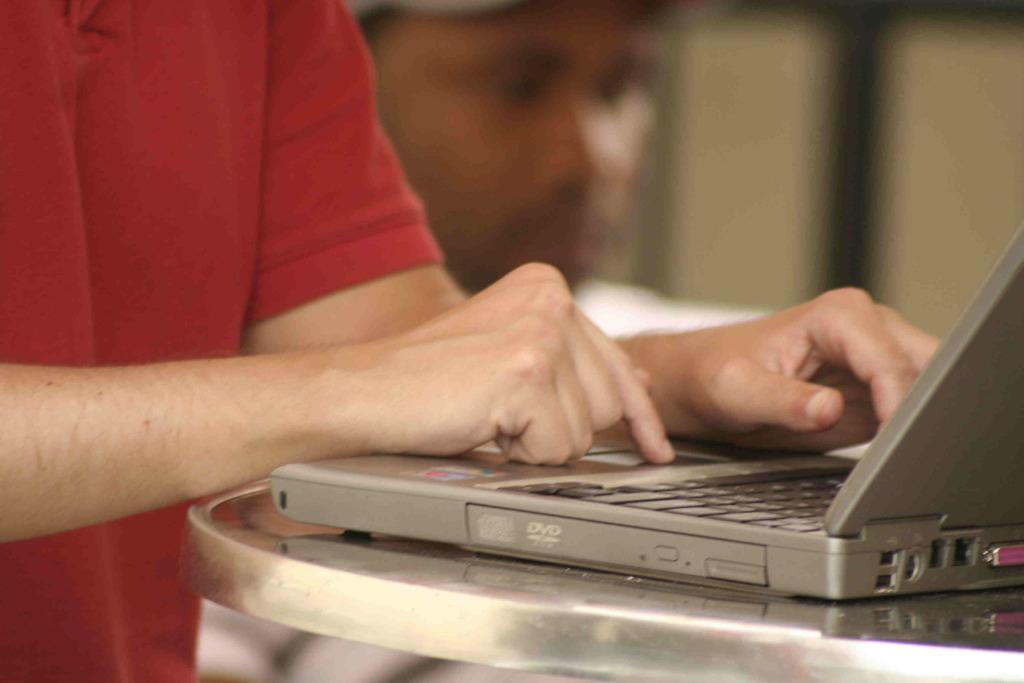<image>
Summarize the visual content of the image. a person touching a computer with the word dvd on it 